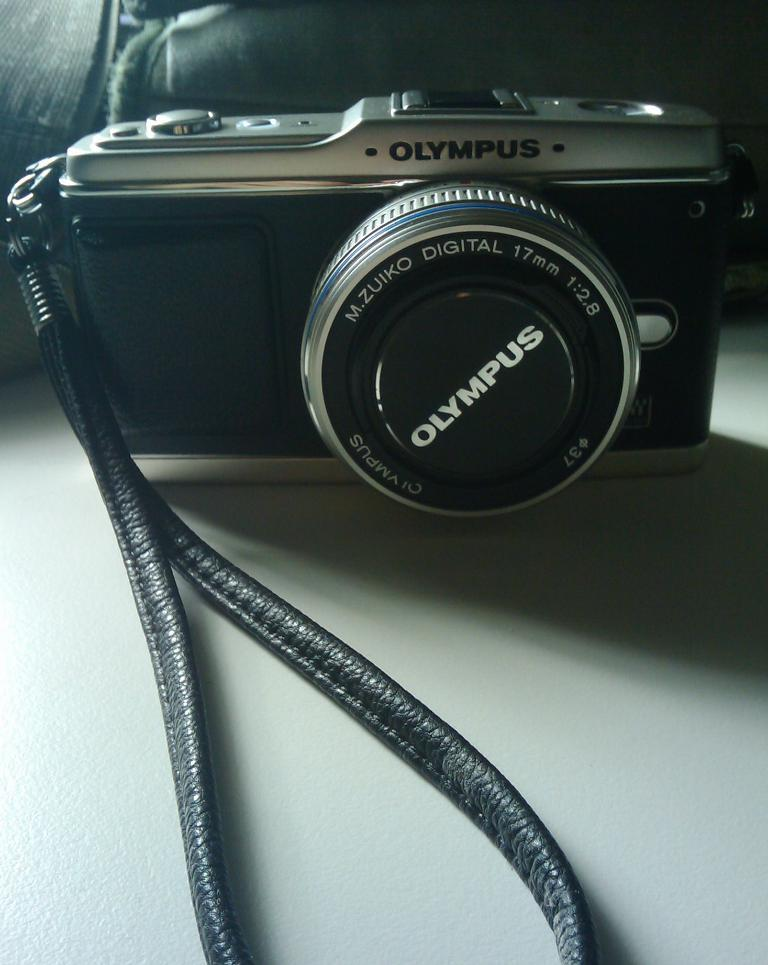What object is the main subject of the image? There is a camera in the image. What else can be seen in the image besides the camera? There is a bag in the image. Where are the camera and bag located? Both the camera and bag are on a table. Can you describe the lighting in the image? The top right corner of the image appears to be dark. What type of songs does the manager in the image enjoy listening to? There is no manager or mention of songs in the image; it only features a camera and a bag on a table. 